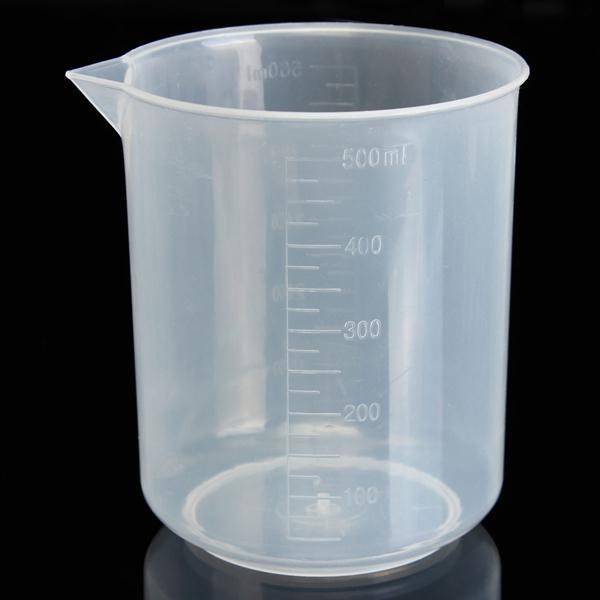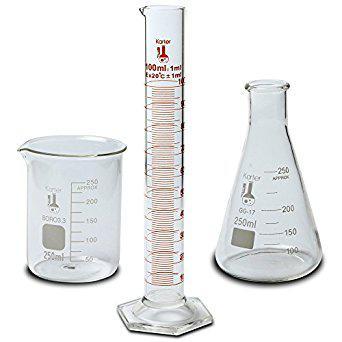The first image is the image on the left, the second image is the image on the right. Analyze the images presented: Is the assertion "Each image includes at least one slender test tube-shaped cylinder that stands on a flat hexagon-shaped base." valid? Answer yes or no. No. The first image is the image on the left, the second image is the image on the right. Analyze the images presented: Is the assertion "There is one cylinder and three beakers." valid? Answer yes or no. Yes. 